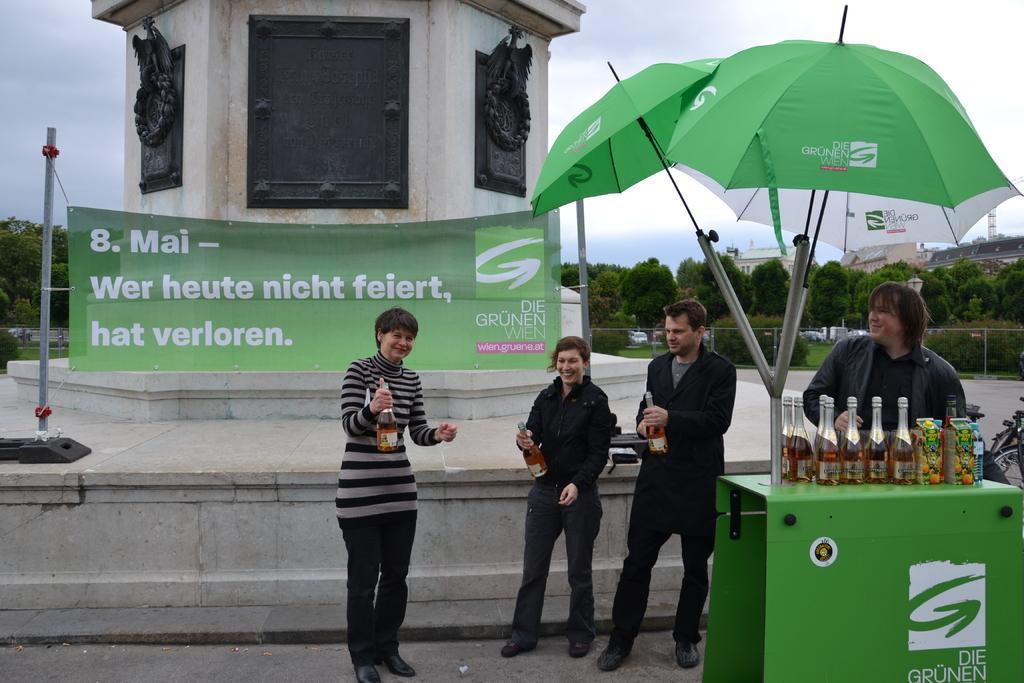In one or two sentences, can you explain what this image depicts? In the picture I can see a metal table on the right side and I can see the glass bottles on the table. I can see the umbrellas. I can see a few persons standing on the floor and they are holding the glass bottle in their hands. In the background, I can see the banner, buildings and trees. There are clouds in the sky. 